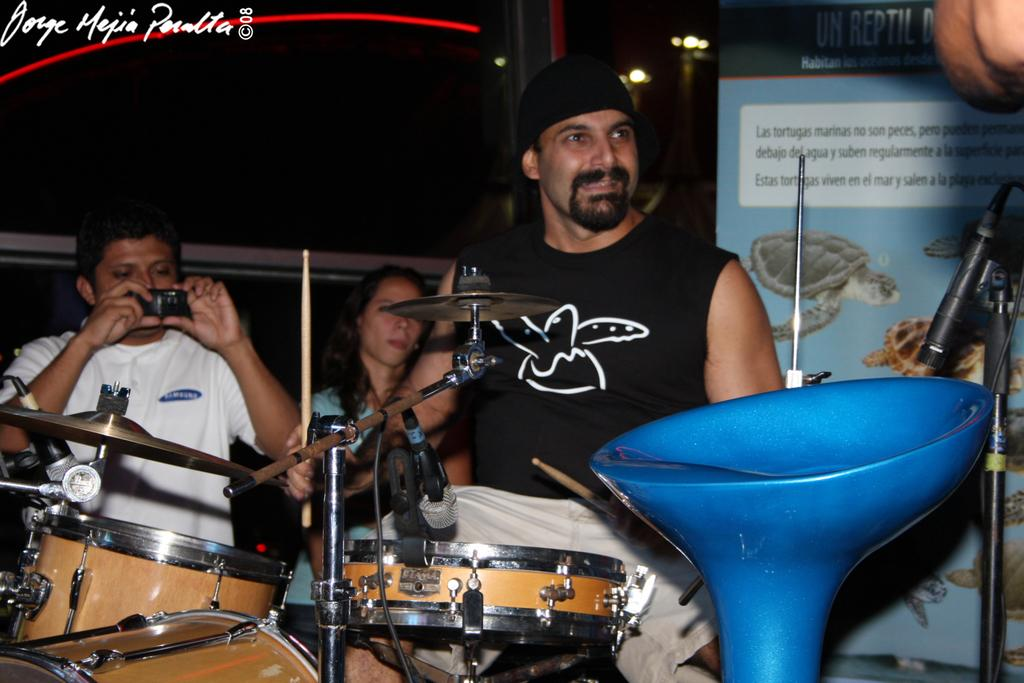What are the people in the image doing? The people in the image are playing musical instruments. What object is present for amplifying sound? There is a microphone in the image. What piece of furniture is in the image? There is a chair in the image. Who is capturing the moment in the image? A person is holding a camera in the image. Can you see a giraffe in the image? No, there is no giraffe present in the image. Is the park visible in the background of the image? The provided facts do not mention a park, so it cannot be determined if it is visible in the background. 